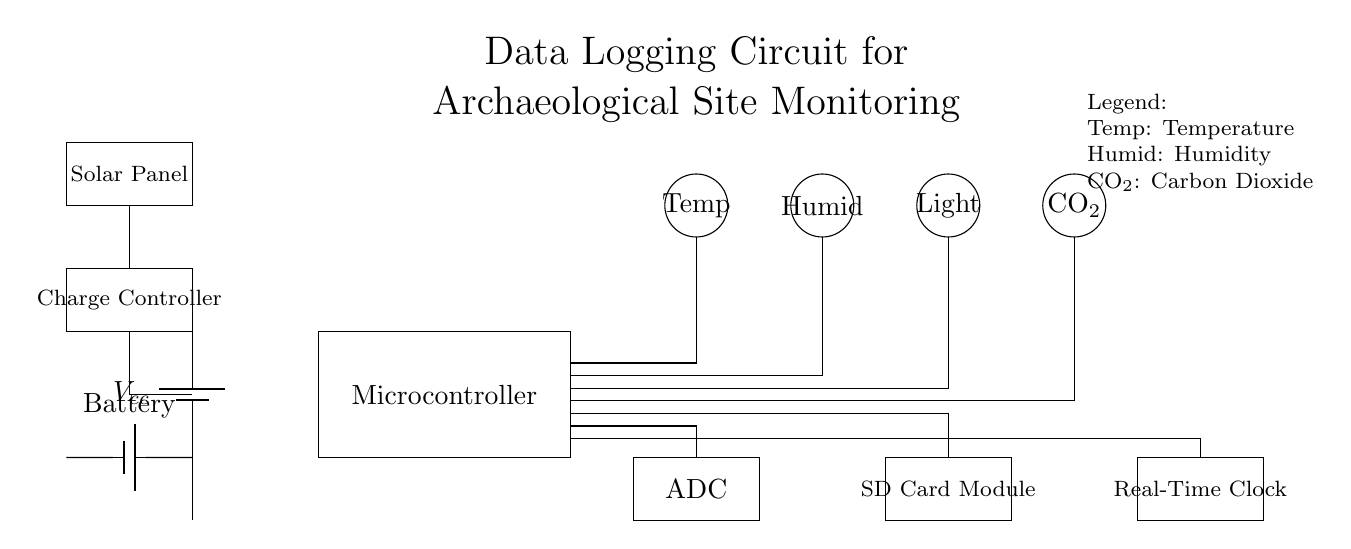What is the function of the microcontroller? The microcontroller is responsible for processing data from the sensors, controlling the data logging functions, and interfacing with the ADC and storage components in the circuit.
Answer: Data processing What is the purpose of the ADC in this circuit? The ADC (Analog to Digital Converter) takes analog signals from the sensors and converts them into digital data that the microcontroller can use for further processing and storage.
Answer: Signal conversion How many sensors are present in this circuit? There are four sensors indicated in the circuit: Temperature, Humidity, Light, and Carbon Dioxide sensors. Counting these provides the total number of sensors.
Answer: Four What is the power source for the circuit? The power source is a combination of a solar panel and a battery, providing the necessary voltage to operate the components of the circuit independently in various environmental conditions.
Answer: Solar panel and battery Which component records time? The Real-Time Clock (RTC) component is responsible for keeping track of the current time and date, which is essential for timestamping the data collected by the sensors.
Answer: Real-Time Clock How does the circuit ensure continuous operation without interruptions? The circuit utilizes a solar panel combined with a charge controller to charge the battery, ensuring a continuous power supply even in varying light conditions for constant operation.
Answer: Solar panel and charge controller 